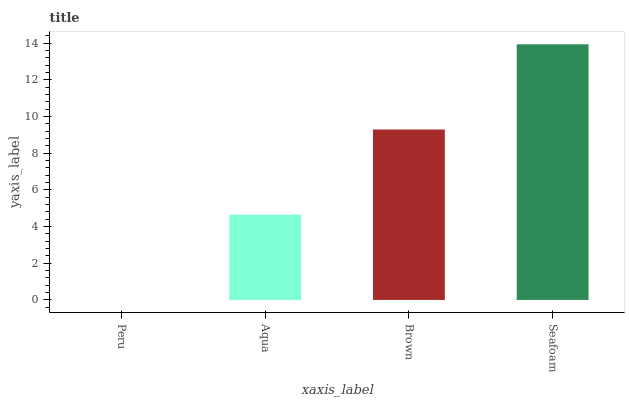Is Aqua the minimum?
Answer yes or no. No. Is Aqua the maximum?
Answer yes or no. No. Is Aqua greater than Peru?
Answer yes or no. Yes. Is Peru less than Aqua?
Answer yes or no. Yes. Is Peru greater than Aqua?
Answer yes or no. No. Is Aqua less than Peru?
Answer yes or no. No. Is Brown the high median?
Answer yes or no. Yes. Is Aqua the low median?
Answer yes or no. Yes. Is Seafoam the high median?
Answer yes or no. No. Is Seafoam the low median?
Answer yes or no. No. 